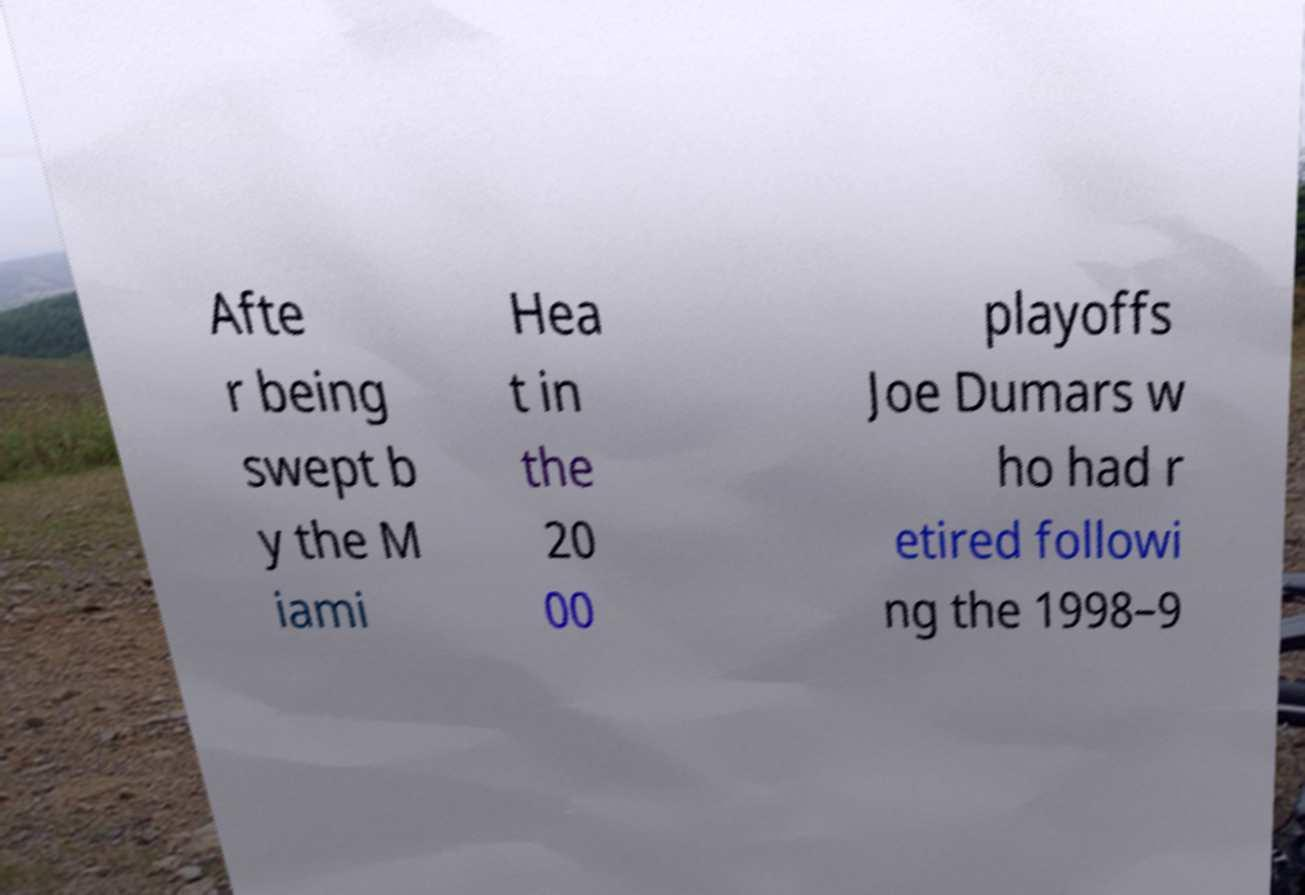For documentation purposes, I need the text within this image transcribed. Could you provide that? Afte r being swept b y the M iami Hea t in the 20 00 playoffs Joe Dumars w ho had r etired followi ng the 1998–9 